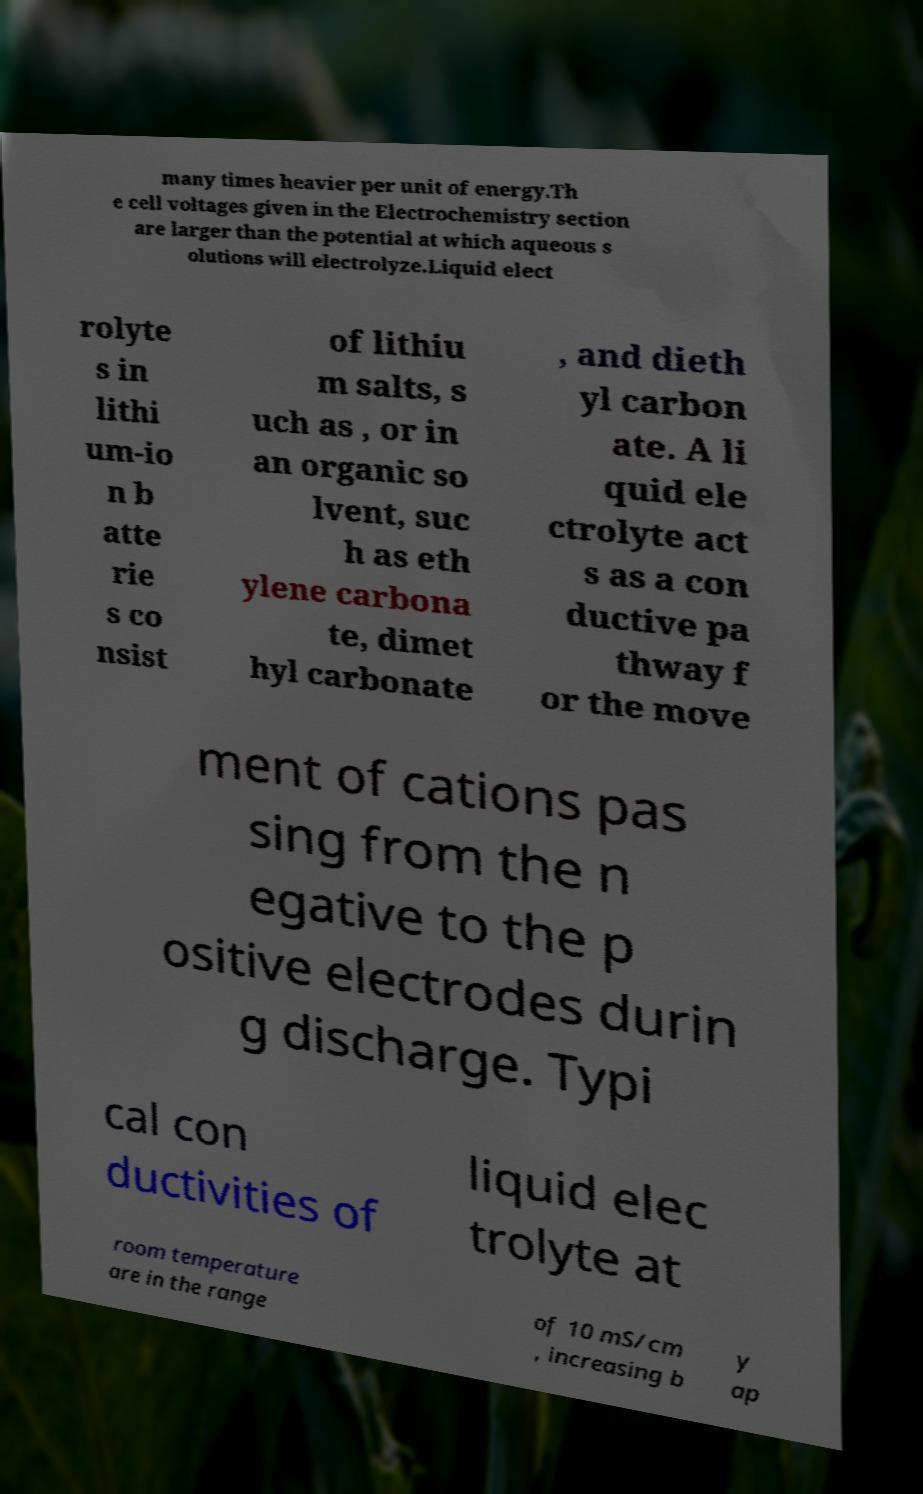Can you read and provide the text displayed in the image?This photo seems to have some interesting text. Can you extract and type it out for me? many times heavier per unit of energy.Th e cell voltages given in the Electrochemistry section are larger than the potential at which aqueous s olutions will electrolyze.Liquid elect rolyte s in lithi um-io n b atte rie s co nsist of lithiu m salts, s uch as , or in an organic so lvent, suc h as eth ylene carbona te, dimet hyl carbonate , and dieth yl carbon ate. A li quid ele ctrolyte act s as a con ductive pa thway f or the move ment of cations pas sing from the n egative to the p ositive electrodes durin g discharge. Typi cal con ductivities of liquid elec trolyte at room temperature are in the range of 10 mS/cm , increasing b y ap 